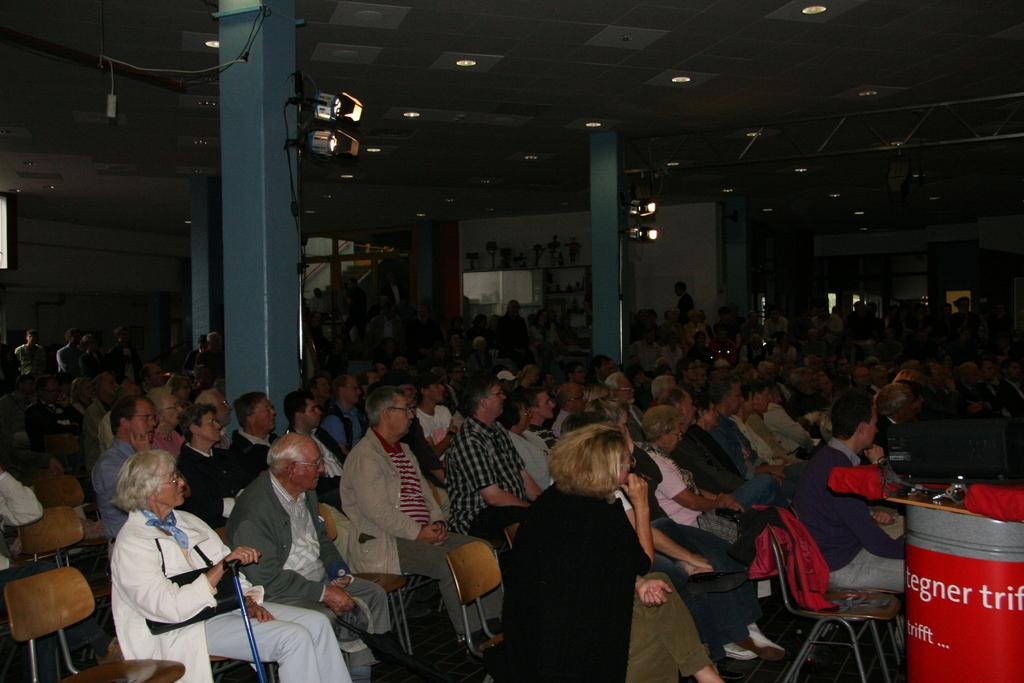What is the main activity taking place in the room? There is a crowd sitting in chairs in the room. What can be found in the middle of the room? There are four pillars in the middle of the room. How many lights are there in the room? There are two lights for each of the two pillars, making a total of four lights. Where is the drum located in the image? The drum is in the bottom right corner of the image. What type of pipe is being smoked by the grandfather in the image? There is no grandfather or pipe present in the image. 